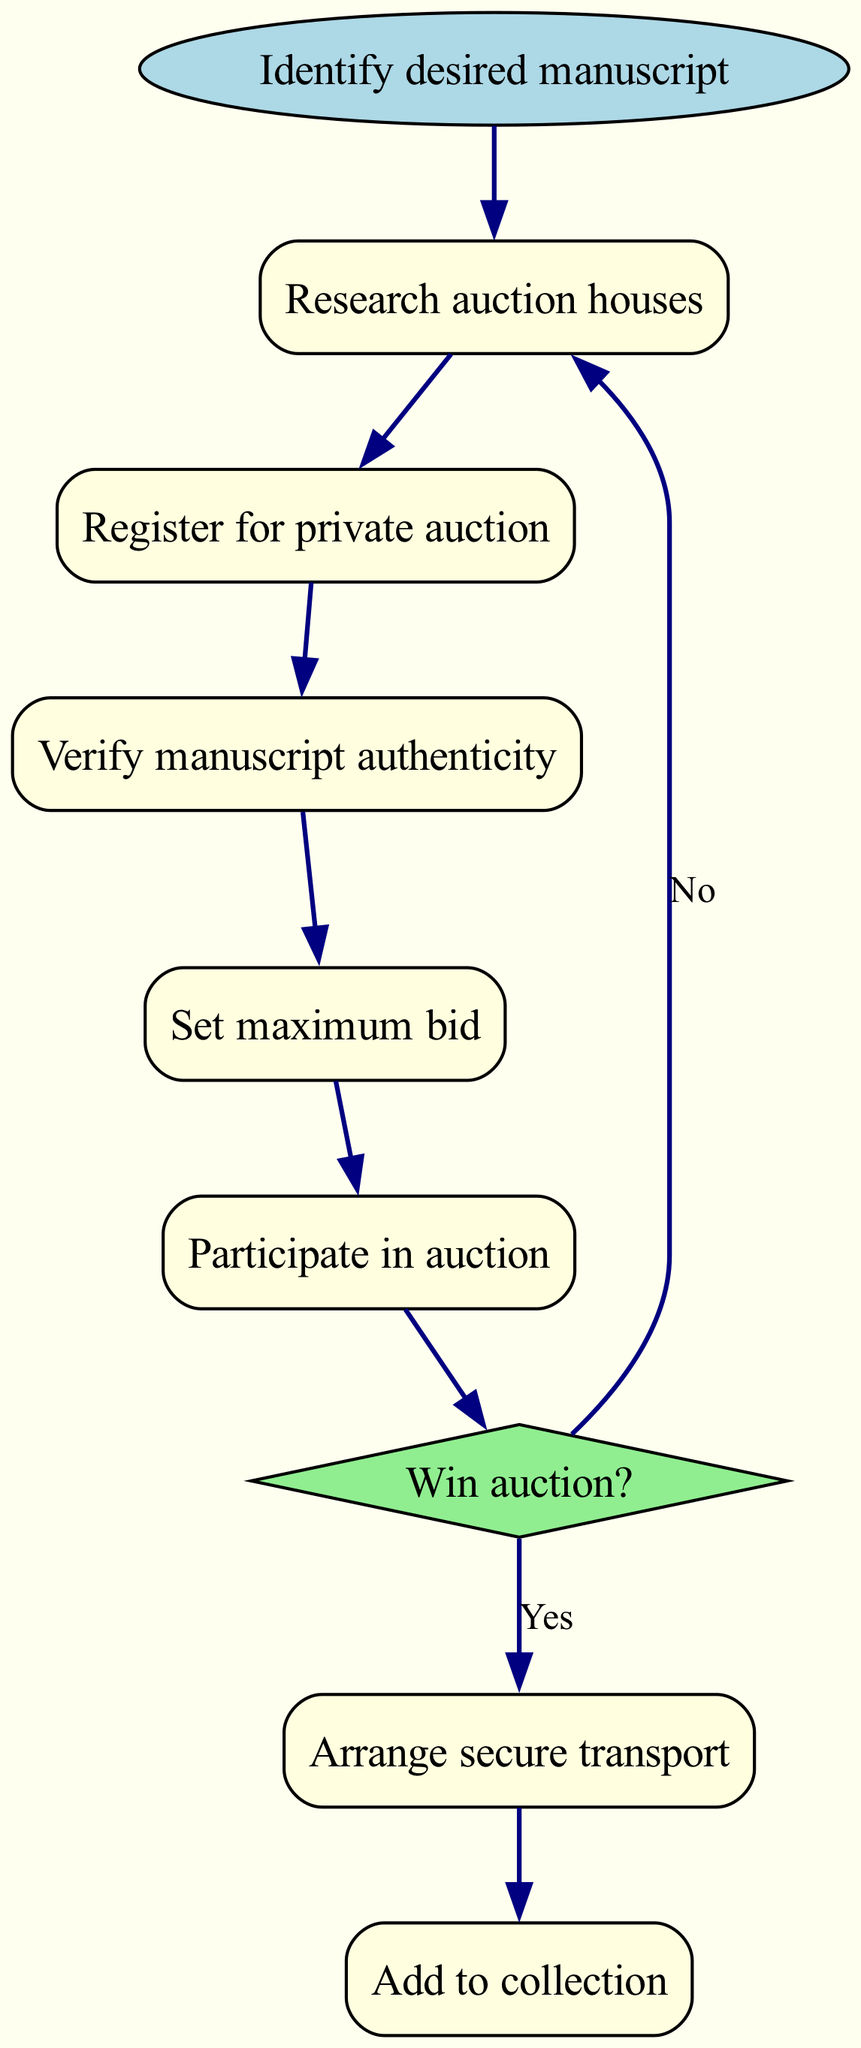What is the first step in acquiring a rare medieval manuscript? The diagram shows that the first step is to "Identify desired manuscript." This is labeled as the start node.
Answer: Identify desired manuscript How many nodes are present in the diagram? Counting all the unique steps and decision points in the diagram, there are a total of eight nodes.
Answer: Eight What is the last action taken after arranging secure transport? The diagram indicates that after arranging secure transport, the final action is to "Add to collection." This signifies the completion of the process.
Answer: Add to collection What happens if you do not win the auction? According to the diagram, if the result of the decision "Win auction?" is "No," the flow returns to "Research auction houses." This implies a need to explore further options.
Answer: Research auction houses How many edges lead from the "Win auction?" node? The "Win auction?" node has two edges leading from it: one for the "Yes" response to "Arrange secure transport" and one for the "No" response looping back to "Research auction houses."
Answer: Two Which node involves setting a financial limit? The diagram shows that the node "Set maximum bid" explicitly involves the action of determining a financial limit for the auction.
Answer: Set maximum bid What is the purpose of the "Verify manuscript authenticity" node? This node is crucial as it ensures that the manuscript being considered is genuine and not a forgery, serving as a checkpoint in the acquisition process.
Answer: Ensure authenticity Before participating in the auction, which step must be completed first? The diagram necessitates that one must first "Set maximum bid" before proceeding to "Participate in auction," indicating that budgeting must come before bidding.
Answer: Set maximum bid 